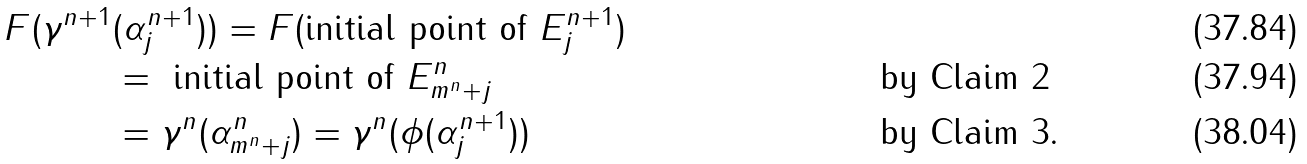<formula> <loc_0><loc_0><loc_500><loc_500>F ( \gamma ^ { n + 1 } & ( \alpha ^ { n + 1 } _ { j } ) ) = F ( \text {initial point of } E ^ { n + 1 } _ { j } ) \\ & = \text { initial point of } E ^ { n } _ { m ^ { n } + j } & & \text { by Claim 2} \\ & = \gamma ^ { n } ( \alpha ^ { n } _ { m ^ { n } + j } ) = \gamma ^ { n } ( \phi ( \alpha ^ { n + 1 } _ { j } ) ) & & \text { by Claim 3.}</formula> 